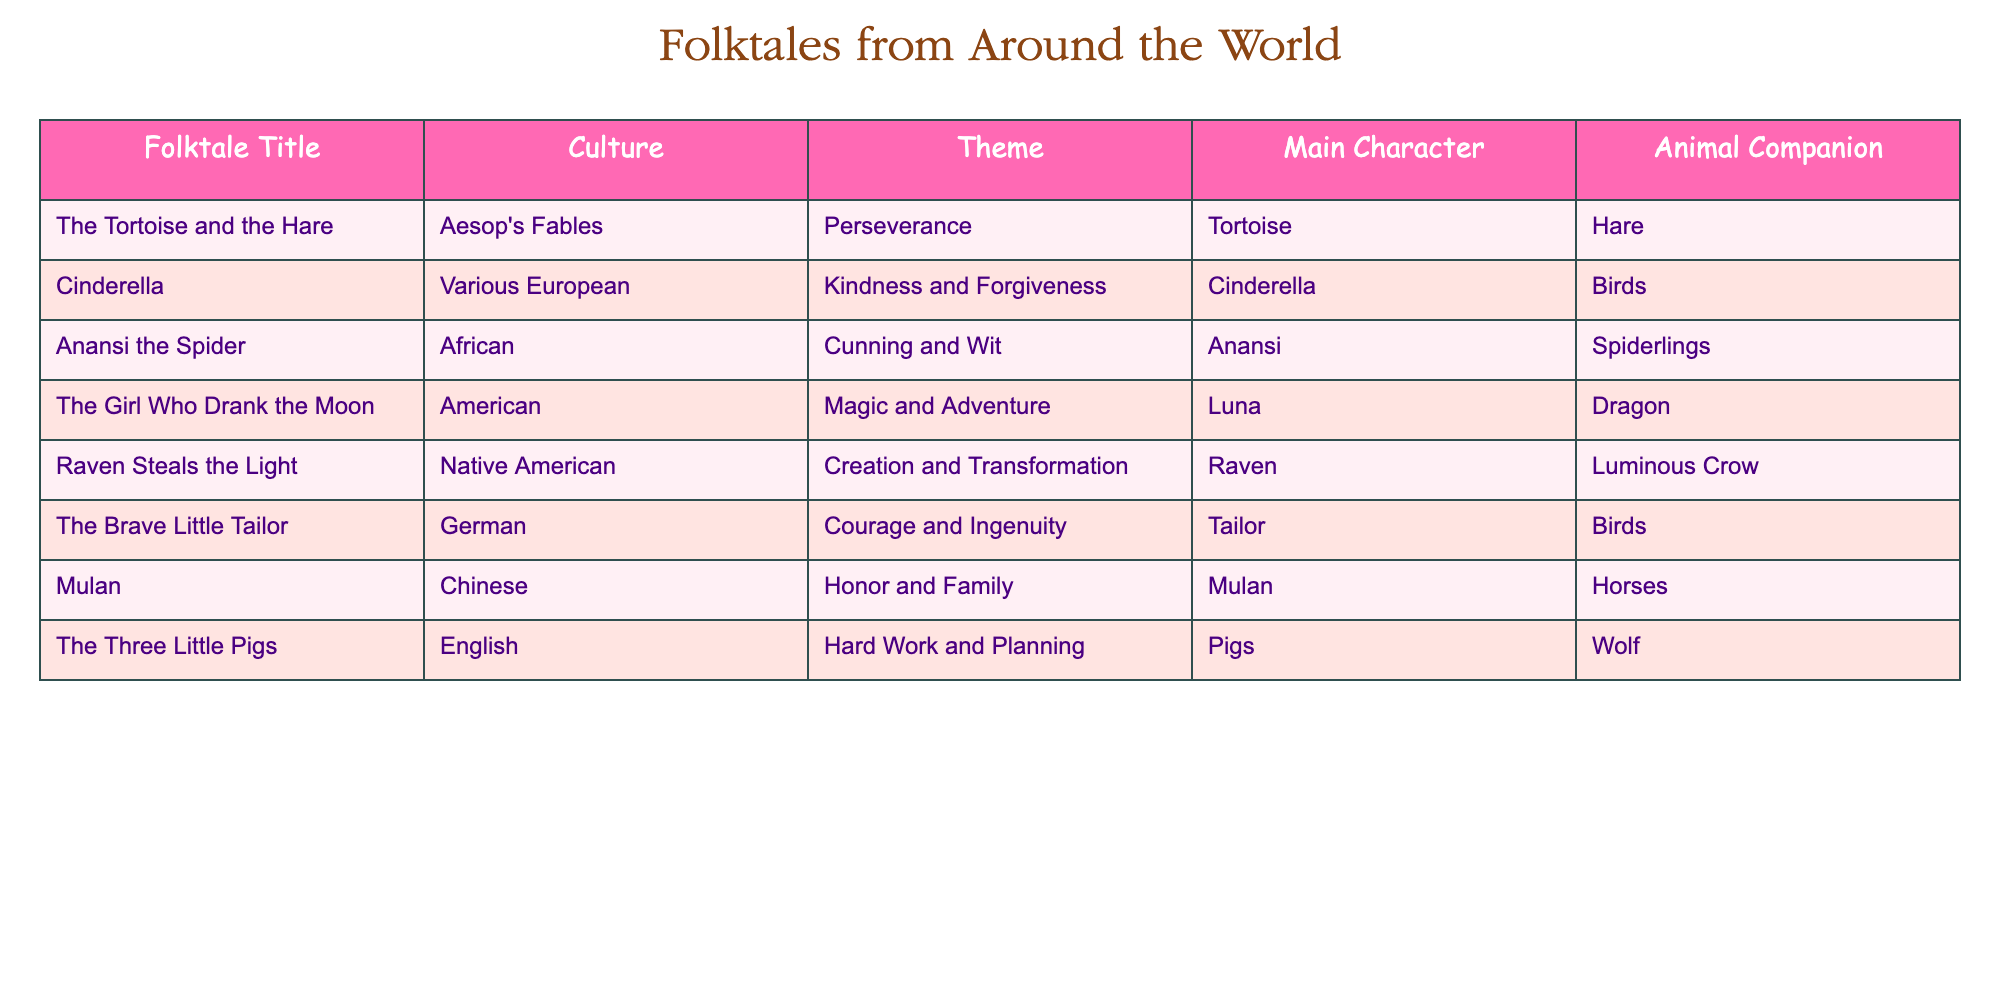What is the theme of "Cinderella"? The table shows that the theme for "Cinderella" is "Kindness and Forgiveness". It's directly listed in the row for that folktale.
Answer: Kindness and Forgiveness Who is the main character in "Anansi the Spider"? In the row for "Anansi the Spider," the main character is identified as "Anansi." This is a straightforward retrieval from the table.
Answer: Anansi How many folktales feature animal companions? The table lists two entries with animal companions: "The Tortoise and the Hare" (Hare) and "Anansi the Spider" (Spiderlings). Therefore, there are 6 tales without mention of animal companions. Adding the tales will give us 8. So the answer is 8.
Answer: 8 Is the main character of "The Girl Who Drank the Moon" Luna? The table confirms that the main character for "The Girl Who Drank the Moon" is indeed "Luna", so this is a true statement.
Answer: Yes Which folktale emphasizes courage and ingenuity? Referring to the table, "The Brave Little Tailor" is indicated as the folktale that emphasizes the theme of "Courage and Ingenuity." This is found directly in its corresponding row.
Answer: The Brave Little Tailor Do more folktales originate from European cultures than from African cultures? From the table, we see that there are four entries from European cultures (Cinderella, Three Little Pigs, The Brave Little Tailor, and Mulan) and one from African cultures (Anansi the Spider). Therefore, the statement is true.
Answer: Yes What is the average number of elements in the themes of the folktales? First, we note all unique themes: Perseverance, Kindness and Forgiveness, Cunning and Wit, Magic and Adventure, Creation and Transformation, Courage and Ingenuity, Honor and Family, Hard Work and Planning. There are 8 distinct themes. Thus, the average is purely dividing by 8 which is just 1 since each folktale has one unique theme and it counts as one.
Answer: 1 Which folktale has a dragon as an animal companion? Looking at the “Animal Companion” column for "The Girl Who Drank the Moon," we see the entry lists "Dragon." Thus, that is the folktale with a dragon as an animal companion.
Answer: The Girl Who Drank the Moon How many folktales include characters that represent animals? In checking the entries in the table, we see that the entries such as "The Tortoise and the Hare," which gives both "Tortoise" and "Hare," include characters that represent animals. We can say that several tales do feature animals. Counting the listings, we note 6 tales do this, coming from the combination seen.
Answer: 6 